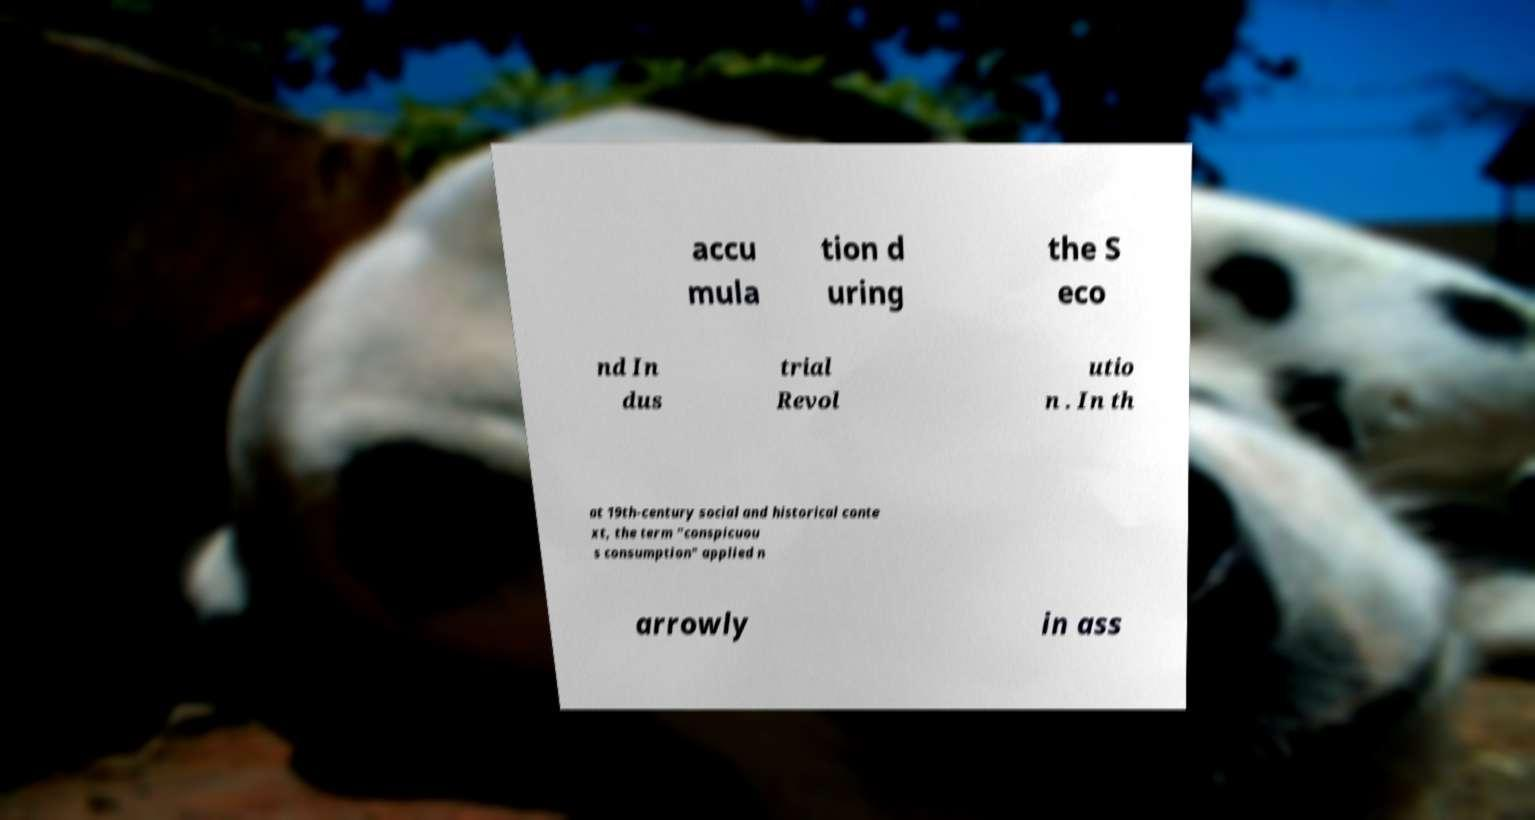Could you assist in decoding the text presented in this image and type it out clearly? accu mula tion d uring the S eco nd In dus trial Revol utio n . In th at 19th-century social and historical conte xt, the term "conspicuou s consumption" applied n arrowly in ass 